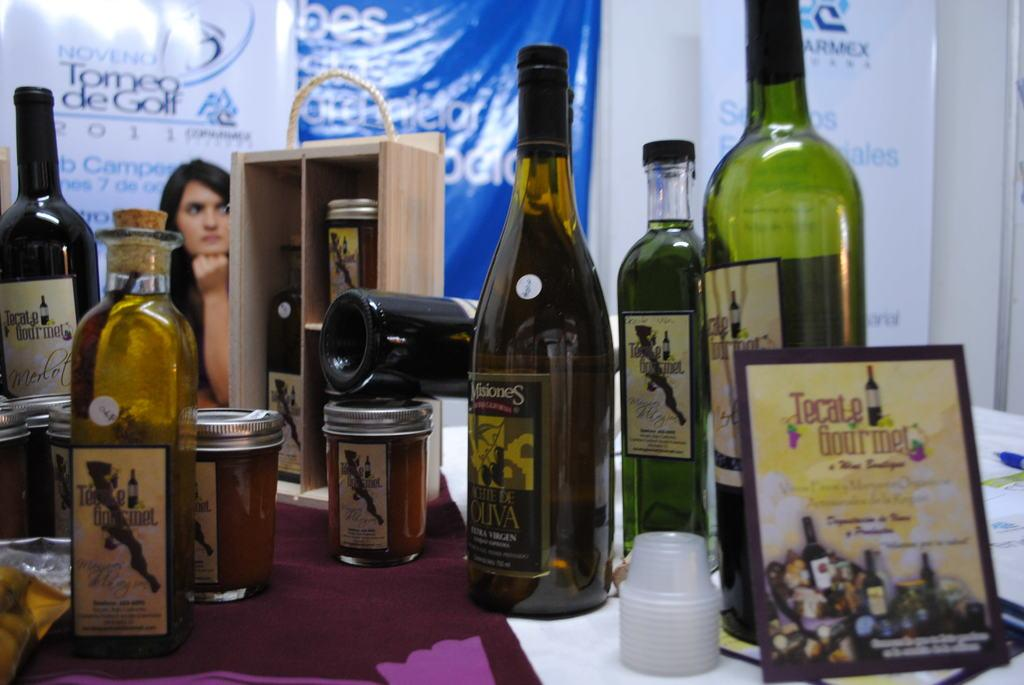<image>
Relay a brief, clear account of the picture shown. A collection of wine bottles and a sign that reads Tecate Gourmet. 